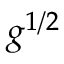<formula> <loc_0><loc_0><loc_500><loc_500>g ^ { 1 / 2 }</formula> 